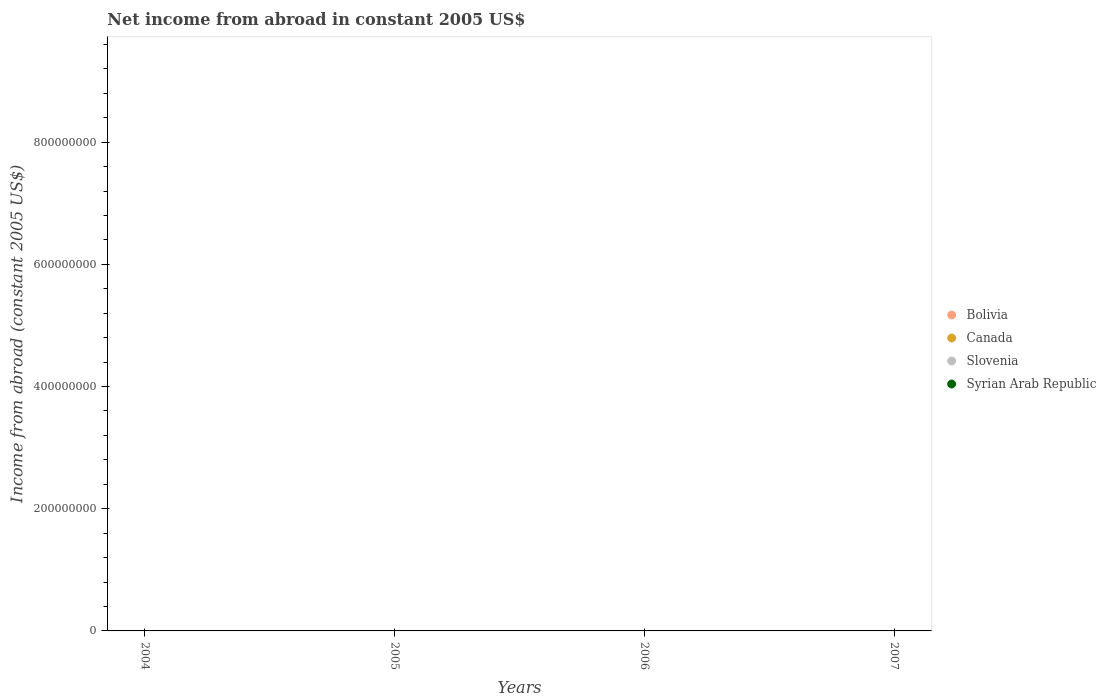Is the number of dotlines equal to the number of legend labels?
Your response must be concise. No. What is the net income from abroad in Canada in 2004?
Your answer should be compact. 0. Across all years, what is the minimum net income from abroad in Bolivia?
Give a very brief answer. 0. What is the total net income from abroad in Canada in the graph?
Your answer should be compact. 0. What is the difference between the net income from abroad in Canada in 2004 and the net income from abroad in Bolivia in 2007?
Your answer should be compact. 0. In how many years, is the net income from abroad in Canada greater than 840000000 US$?
Your response must be concise. 0. In how many years, is the net income from abroad in Bolivia greater than the average net income from abroad in Bolivia taken over all years?
Your answer should be very brief. 0. Is the net income from abroad in Syrian Arab Republic strictly less than the net income from abroad in Canada over the years?
Provide a short and direct response. No. How many dotlines are there?
Your answer should be very brief. 0. How many years are there in the graph?
Keep it short and to the point. 4. What is the difference between two consecutive major ticks on the Y-axis?
Provide a short and direct response. 2.00e+08. Are the values on the major ticks of Y-axis written in scientific E-notation?
Ensure brevity in your answer.  No. How many legend labels are there?
Offer a very short reply. 4. What is the title of the graph?
Your answer should be compact. Net income from abroad in constant 2005 US$. Does "Ghana" appear as one of the legend labels in the graph?
Provide a succinct answer. No. What is the label or title of the Y-axis?
Offer a very short reply. Income from abroad (constant 2005 US$). What is the Income from abroad (constant 2005 US$) of Bolivia in 2004?
Your response must be concise. 0. What is the Income from abroad (constant 2005 US$) of Canada in 2004?
Your response must be concise. 0. What is the Income from abroad (constant 2005 US$) in Syrian Arab Republic in 2004?
Provide a short and direct response. 0. What is the Income from abroad (constant 2005 US$) of Canada in 2005?
Keep it short and to the point. 0. What is the Income from abroad (constant 2005 US$) in Syrian Arab Republic in 2005?
Give a very brief answer. 0. What is the Income from abroad (constant 2005 US$) in Canada in 2006?
Offer a very short reply. 0. What is the Income from abroad (constant 2005 US$) of Slovenia in 2006?
Give a very brief answer. 0. What is the Income from abroad (constant 2005 US$) of Bolivia in 2007?
Keep it short and to the point. 0. What is the Income from abroad (constant 2005 US$) in Syrian Arab Republic in 2007?
Offer a very short reply. 0. What is the total Income from abroad (constant 2005 US$) of Bolivia in the graph?
Offer a terse response. 0. What is the total Income from abroad (constant 2005 US$) of Canada in the graph?
Offer a terse response. 0. What is the total Income from abroad (constant 2005 US$) in Slovenia in the graph?
Make the answer very short. 0. What is the average Income from abroad (constant 2005 US$) of Bolivia per year?
Offer a very short reply. 0. What is the average Income from abroad (constant 2005 US$) of Slovenia per year?
Provide a succinct answer. 0. 